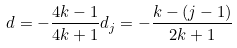Convert formula to latex. <formula><loc_0><loc_0><loc_500><loc_500>d = - \frac { 4 k - 1 } { 4 k + 1 } d _ { j } = - \frac { k - ( j - 1 ) } { 2 k + 1 }</formula> 